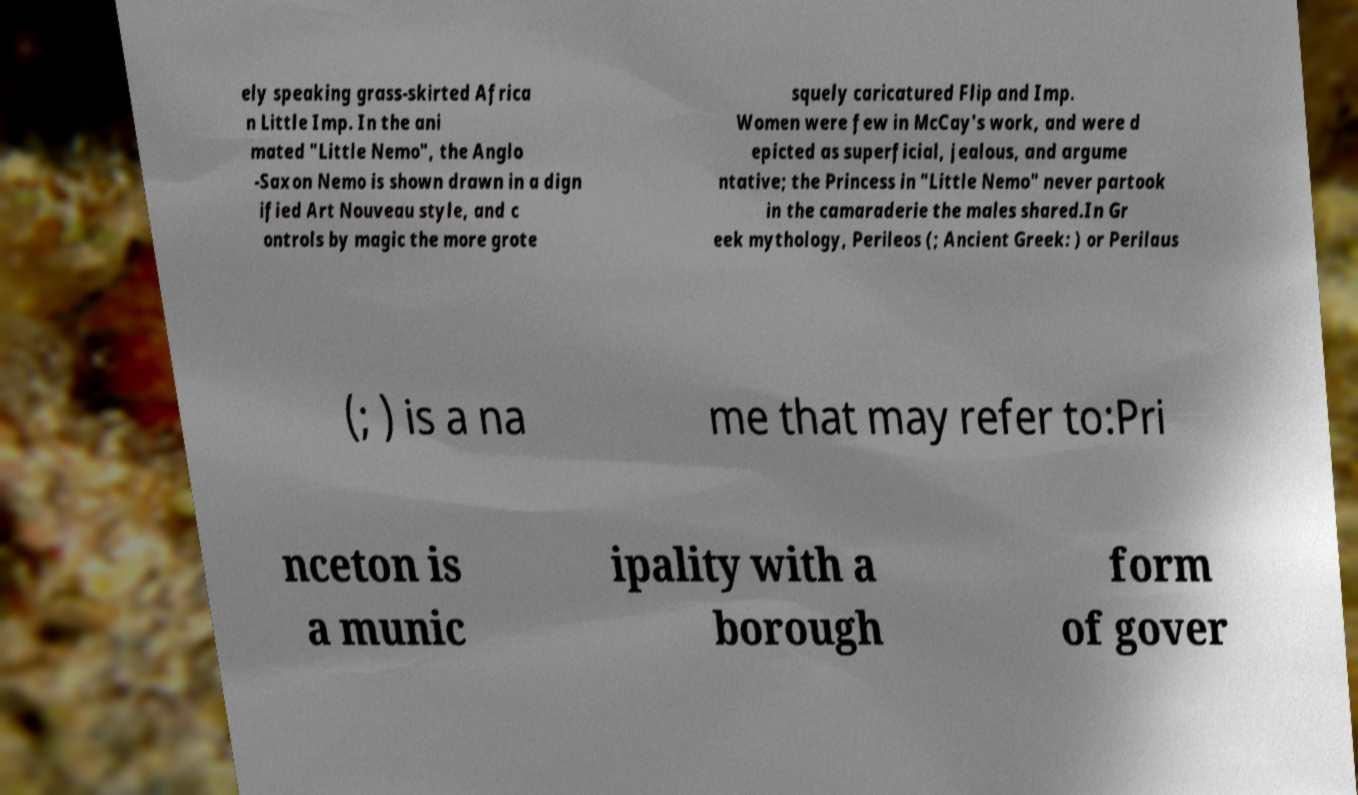Please read and relay the text visible in this image. What does it say? ely speaking grass-skirted Africa n Little Imp. In the ani mated "Little Nemo", the Anglo -Saxon Nemo is shown drawn in a dign ified Art Nouveau style, and c ontrols by magic the more grote squely caricatured Flip and Imp. Women were few in McCay's work, and were d epicted as superficial, jealous, and argume ntative; the Princess in "Little Nemo" never partook in the camaraderie the males shared.In Gr eek mythology, Perileos (; Ancient Greek: ) or Perilaus (; ) is a na me that may refer to:Pri nceton is a munic ipality with a borough form of gover 